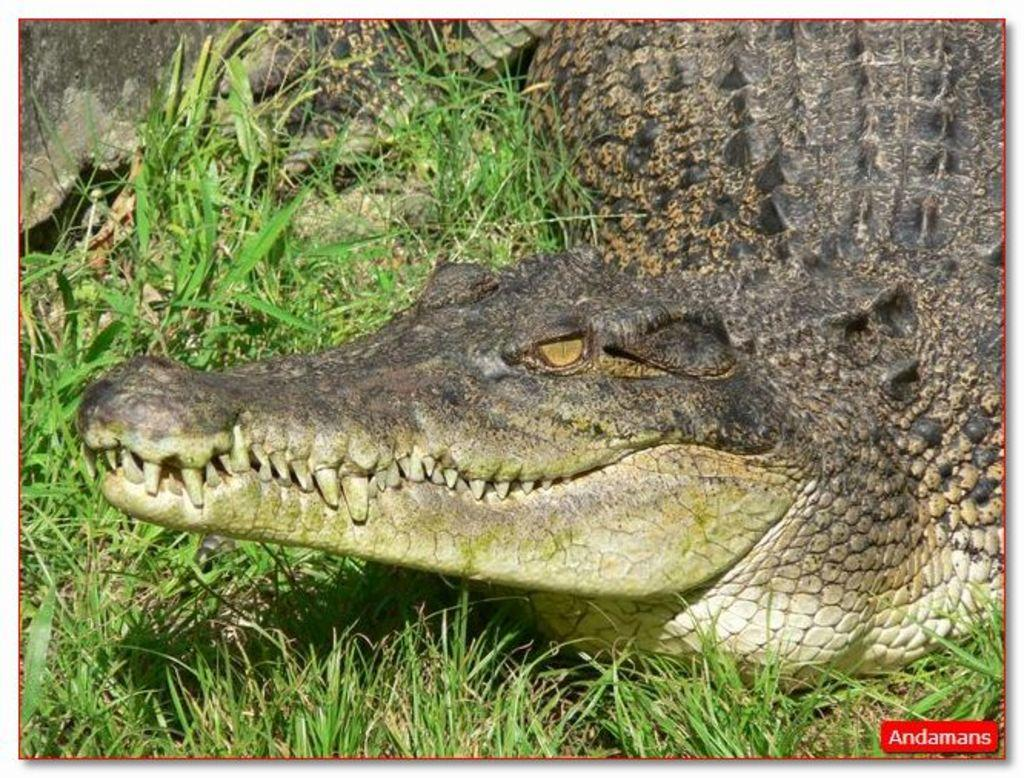What animal is the main subject of the image? There is a crocodile in the image. Where is the crocodile located? The crocodile is on the grass. How close is the crocodile to the viewer in the image? The crocodile is in the foreground of the image. What emotion is the crocodile displaying in the image? The image does not show any indication of the crocodile's emotions, so it cannot be determined from the image. 